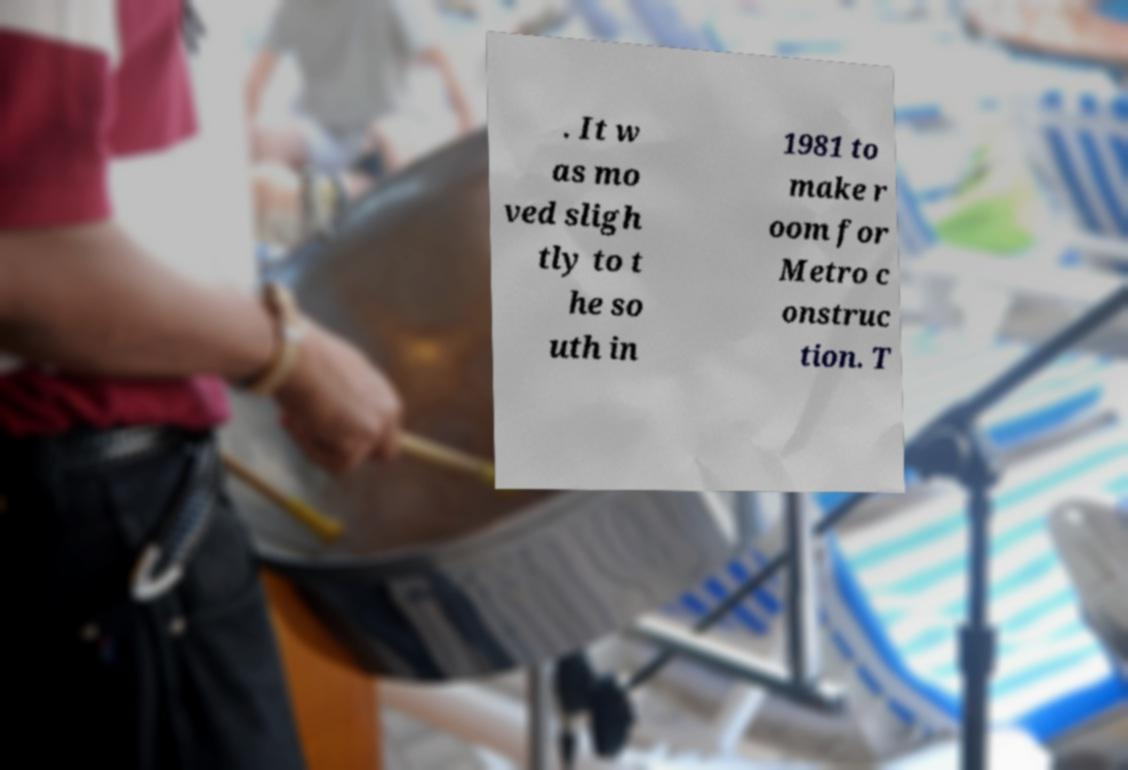I need the written content from this picture converted into text. Can you do that? . It w as mo ved sligh tly to t he so uth in 1981 to make r oom for Metro c onstruc tion. T 